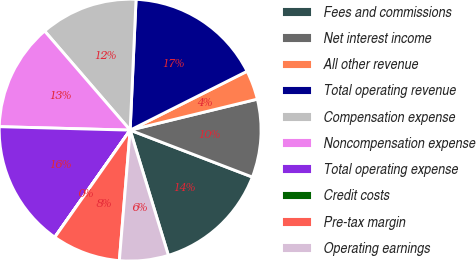Convert chart to OTSL. <chart><loc_0><loc_0><loc_500><loc_500><pie_chart><fcel>Fees and commissions<fcel>Net interest income<fcel>All other revenue<fcel>Total operating revenue<fcel>Compensation expense<fcel>Noncompensation expense<fcel>Total operating expense<fcel>Credit costs<fcel>Pre-tax margin<fcel>Operating earnings<nl><fcel>14.45%<fcel>9.64%<fcel>3.62%<fcel>16.86%<fcel>12.05%<fcel>13.25%<fcel>15.66%<fcel>0.01%<fcel>8.44%<fcel>6.03%<nl></chart> 